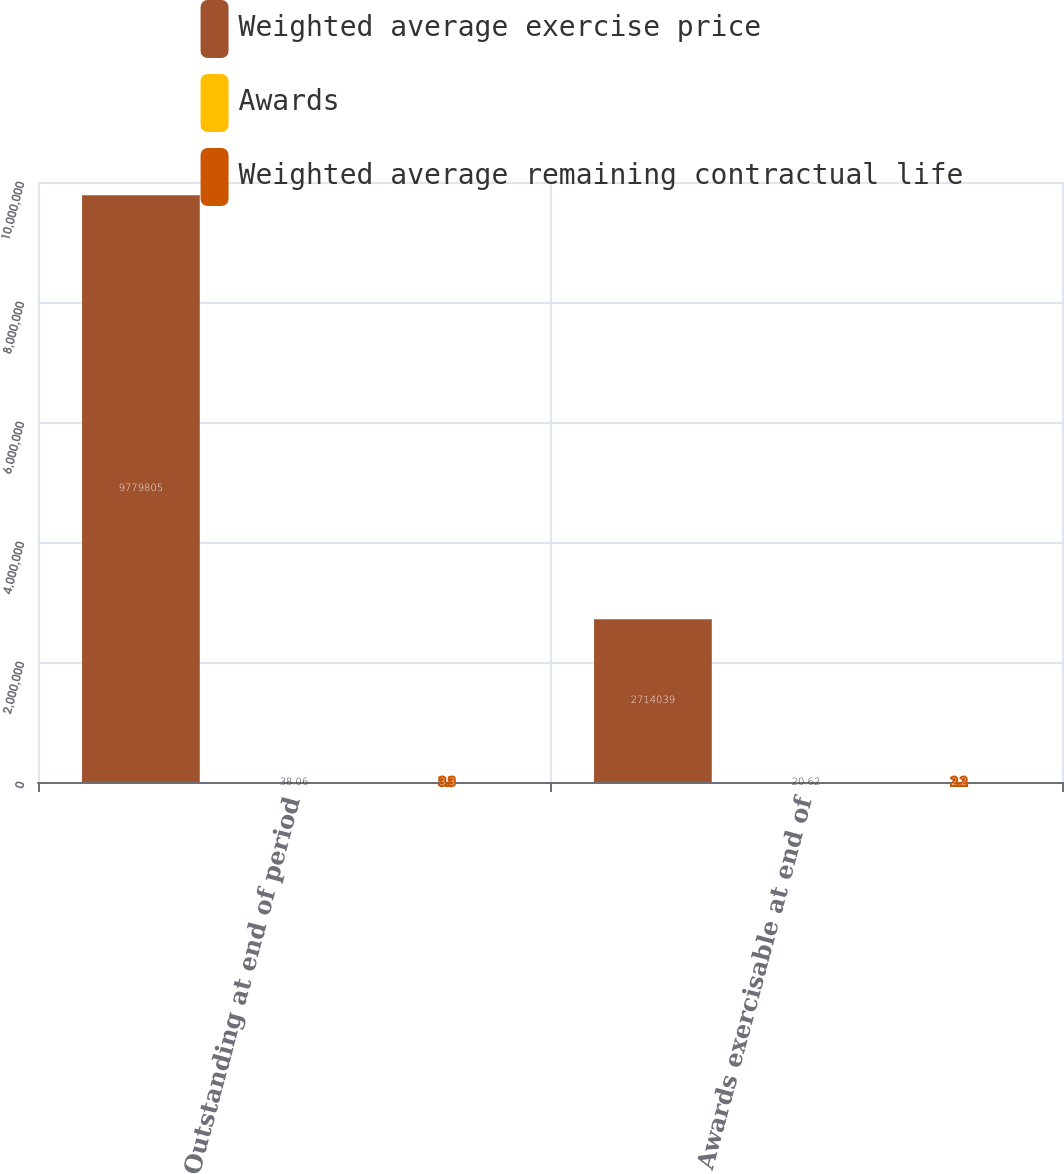Convert chart. <chart><loc_0><loc_0><loc_500><loc_500><stacked_bar_chart><ecel><fcel>Outstanding at end of period<fcel>Awards exercisable at end of<nl><fcel>Weighted average exercise price<fcel>9.7798e+06<fcel>2.71404e+06<nl><fcel>Awards<fcel>38.06<fcel>20.62<nl><fcel>Weighted average remaining contractual life<fcel>3.3<fcel>2.2<nl></chart> 